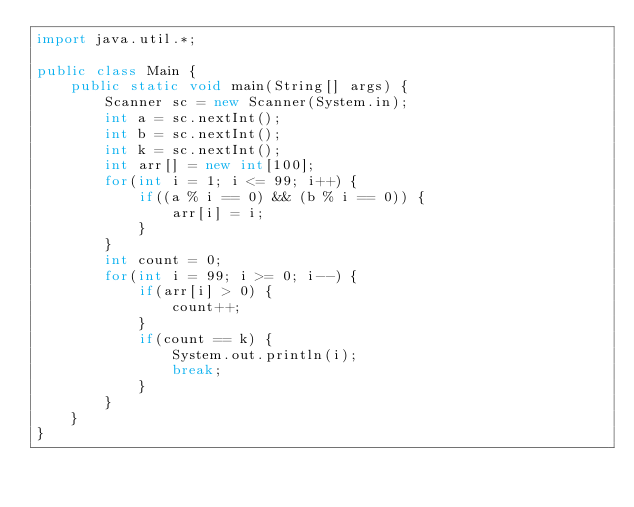Convert code to text. <code><loc_0><loc_0><loc_500><loc_500><_Java_>import java.util.*;

public class Main {
    public static void main(String[] args) {
        Scanner sc = new Scanner(System.in);
        int a = sc.nextInt();
        int b = sc.nextInt();
        int k = sc.nextInt();
        int arr[] = new int[100];
        for(int i = 1; i <= 99; i++) {
            if((a % i == 0) && (b % i == 0)) {
                arr[i] = i;
            }
        }
        int count = 0;
        for(int i = 99; i >= 0; i--) {
            if(arr[i] > 0) {
                count++;
            }
            if(count == k) {
                System.out.println(i);
                break;
            }
        }
    }
}
</code> 